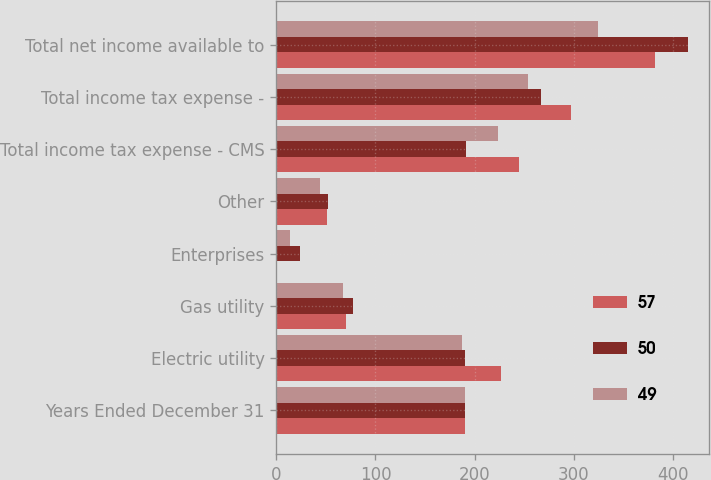<chart> <loc_0><loc_0><loc_500><loc_500><stacked_bar_chart><ecel><fcel>Years Ended December 31<fcel>Electric utility<fcel>Gas utility<fcel>Enterprises<fcel>Other<fcel>Total income tax expense - CMS<fcel>Total income tax expense -<fcel>Total net income available to<nl><fcel>57<fcel>190<fcel>227<fcel>70<fcel>1<fcel>51<fcel>245<fcel>297<fcel>382<nl><fcel>50<fcel>190<fcel>190<fcel>77<fcel>24<fcel>52<fcel>191<fcel>267<fcel>415<nl><fcel>49<fcel>190<fcel>187<fcel>67<fcel>14<fcel>44<fcel>224<fcel>254<fcel>324<nl></chart> 